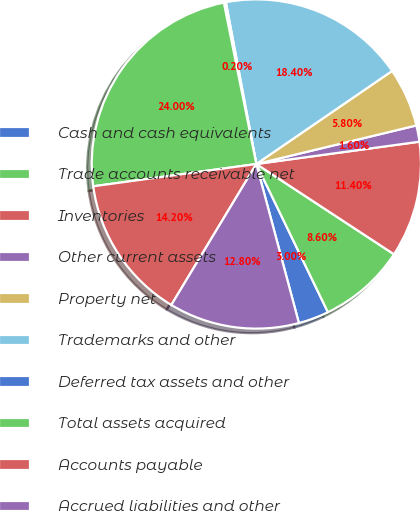Convert chart to OTSL. <chart><loc_0><loc_0><loc_500><loc_500><pie_chart><fcel>Cash and cash equivalents<fcel>Trade accounts receivable net<fcel>Inventories<fcel>Other current assets<fcel>Property net<fcel>Trademarks and other<fcel>Deferred tax assets and other<fcel>Total assets acquired<fcel>Accounts payable<fcel>Accrued liabilities and other<nl><fcel>3.0%<fcel>8.6%<fcel>11.4%<fcel>1.6%<fcel>5.8%<fcel>18.4%<fcel>0.2%<fcel>24.0%<fcel>14.2%<fcel>12.8%<nl></chart> 